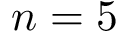<formula> <loc_0><loc_0><loc_500><loc_500>n = 5</formula> 